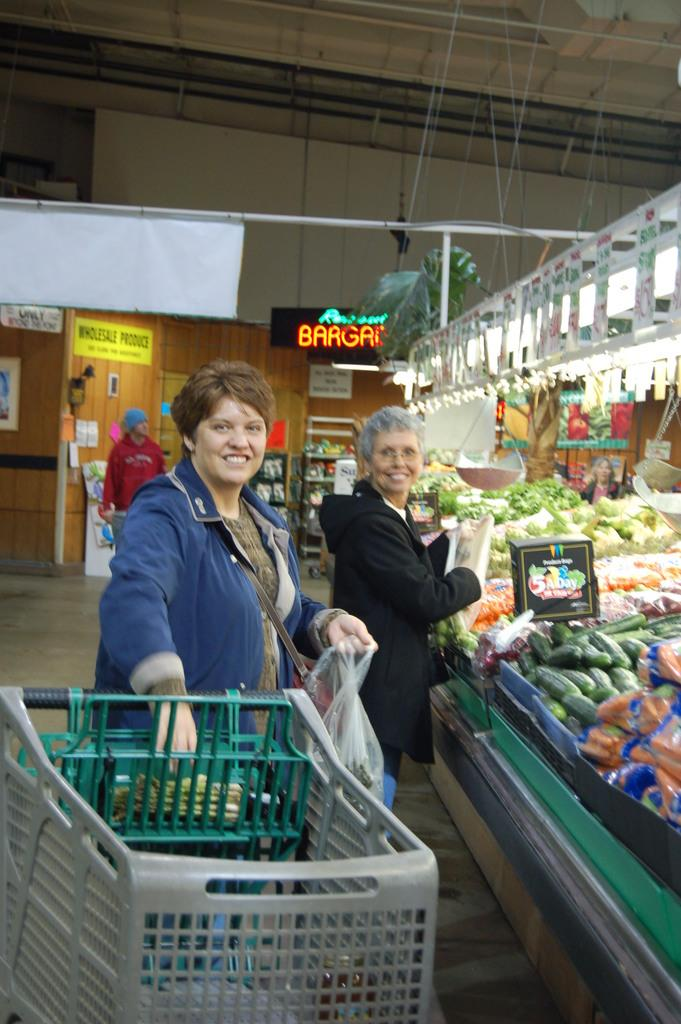Provide a one-sentence caption for the provided image. People shop at a store called Wholesale Produce. 